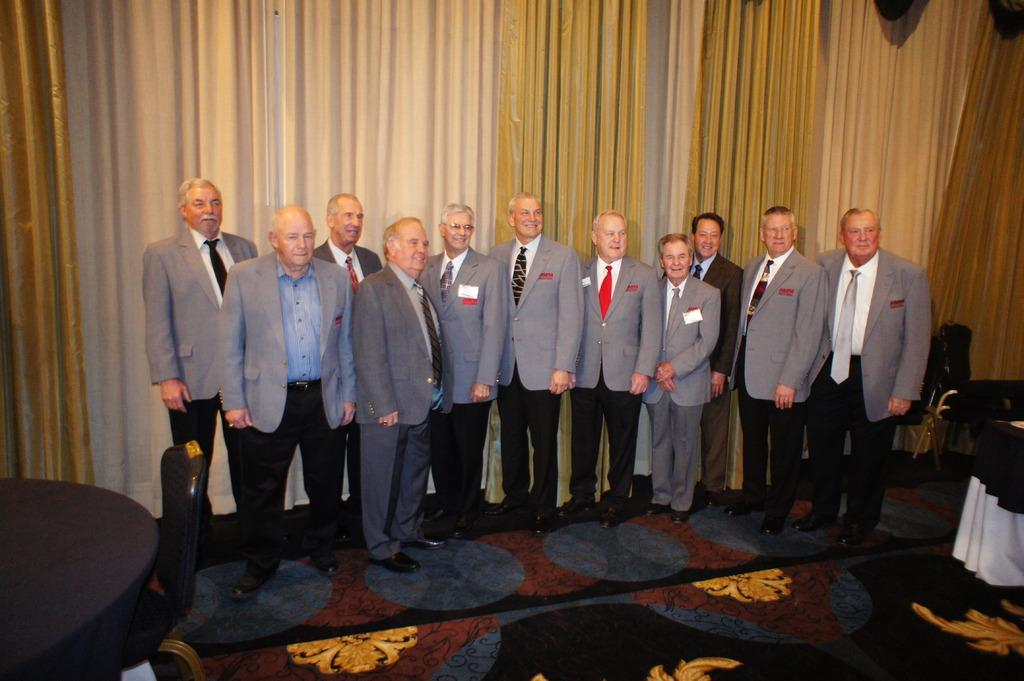How many people are in the image? There is a group of people in the image. What type of furniture is present in the image? There are tables and chairs in the image. Where are the tables and chairs located? The tables and chairs are on the ground. What can be seen in the background of the image? There are curtains visible in the background of the image. What type of blood and flesh can be seen on the tables in the image? There is no blood or flesh present on the tables in the image. 